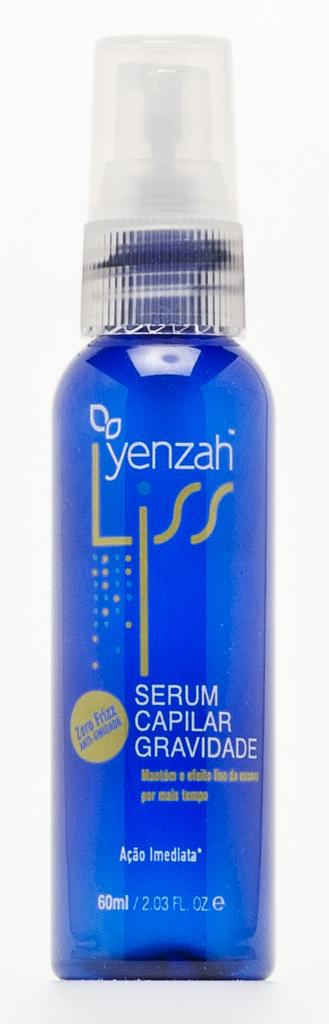<image>
Present a compact description of the photo's key features. Blue bottle of Yenzah Liss with a cup cap. 